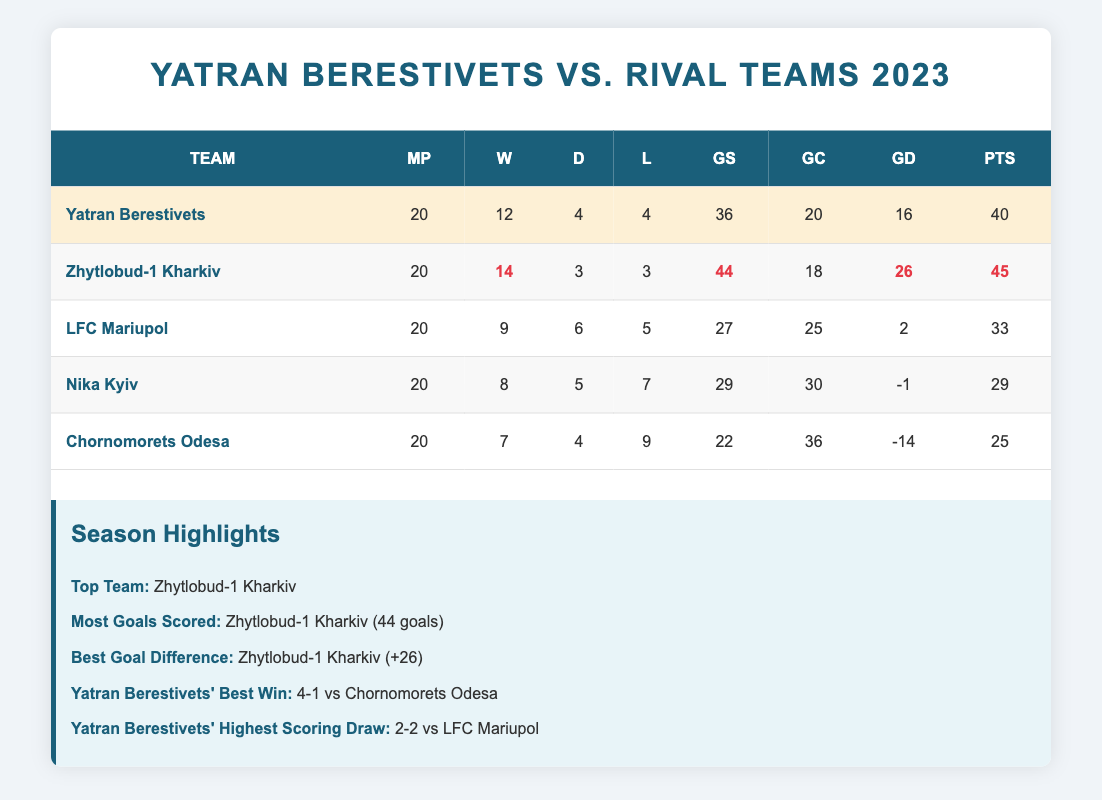What is the total number of matches played by Yatran Berestivets? Yatran Berestivets has played a total of 20 matches, as indicated in the "matches_played" column for their row in the table.
Answer: 20 Which team has the best goal difference? The team with the best goal difference is Zhytlobud-1 Kharkiv, with a goal difference of +26, highlighted in the table under "goal_difference."
Answer: Zhytlobud-1 Kharkiv Did Yatran Berestivets have more wins than LFC Mariupol? Yes, Yatran Berestivets won 12 matches while LFC Mariupol won 9 matches, so they have more wins. The comparison is made using their respective "wins" values from the table.
Answer: Yes What is the points difference between Yatran Berestivets and Zhytlobud-1 Kharkiv? Yatran Berestivets has 40 points while Zhytlobud-1 Kharkiv has 45 points. To find the difference, subtract Yatran's points from Zhytlobud's: 45 - 40 = 5.
Answer: 5 How many total goals were scored by all teams combined? To find the total goals scored, sum the individual goals scored by each team: 36 (Yatran) + 44 (Zhytlobud-1) + 27 (LFC) + 29 (Nika) + 22 (Chorno) = 158.
Answer: 158 Which team scored the fewest goals? Chornomorets Odesa scored the fewest goals, with a total of 22 goals, as indicated in the "goals_scored" column of the table.
Answer: Chornomorets Odesa If we compare the number of draws between Yatran Berestivets and Nika Kyiv, who had more? Yatran Berestivets had 4 draws and Nika Kyiv had 5 draws. Since 5 is greater than 4, Nika Kyiv had more draws than Yatran.
Answer: Nika Kyiv What is the average number of goals scored per match by Yatran Berestivets? To find the average number of goals scored per match, divide the goals scored (36) by the matches played (20): 36 / 20 = 1.8.
Answer: 1.8 How does Yatran Berestivets' goal difference compare to that of Nika Kyiv? Yatran Berestivets has a goal difference of +16, while Nika Kyiv has a goal difference of -1. This shows that Yatran's goal difference is significantly better.
Answer: Yatran Berestivets is better How many more points does Zhytlobud-1 Kharkiv have than Yatran Berestivets? Zhytlobud-1 Kharkiv has 45 points, while Yatran Berestivets has 40 points. The difference is calculated by subtracting Yatran's points from Zhytlobud's: 45 - 40 = 5.
Answer: 5 